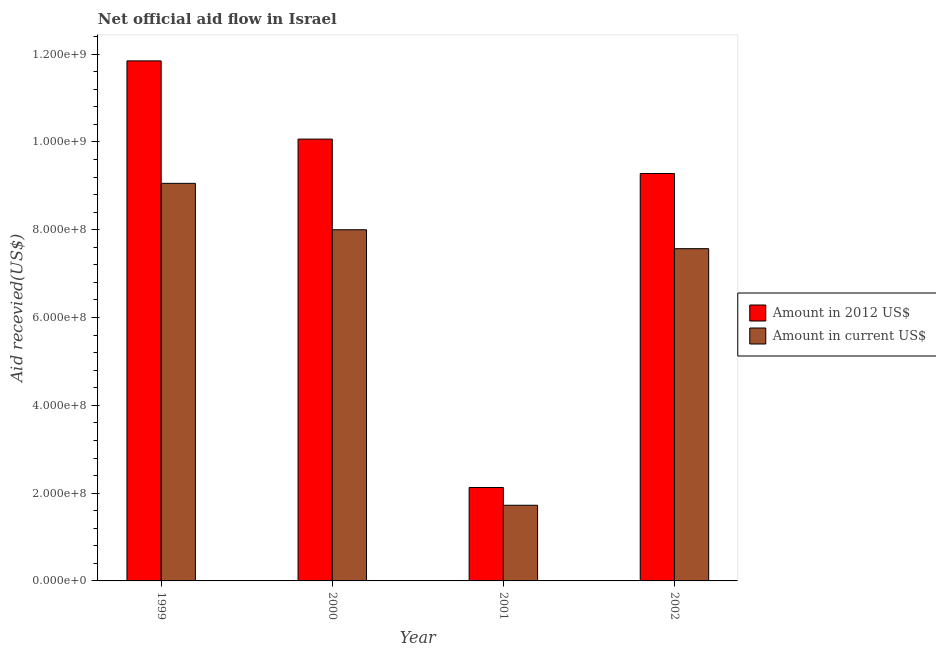How many different coloured bars are there?
Your answer should be compact. 2. How many bars are there on the 1st tick from the left?
Offer a very short reply. 2. How many bars are there on the 3rd tick from the right?
Your answer should be very brief. 2. In how many cases, is the number of bars for a given year not equal to the number of legend labels?
Offer a terse response. 0. What is the amount of aid received(expressed in us$) in 2001?
Offer a very short reply. 1.72e+08. Across all years, what is the maximum amount of aid received(expressed in 2012 us$)?
Your answer should be compact. 1.18e+09. Across all years, what is the minimum amount of aid received(expressed in 2012 us$)?
Give a very brief answer. 2.13e+08. In which year was the amount of aid received(expressed in us$) maximum?
Make the answer very short. 1999. In which year was the amount of aid received(expressed in us$) minimum?
Your answer should be very brief. 2001. What is the total amount of aid received(expressed in us$) in the graph?
Offer a very short reply. 2.63e+09. What is the difference between the amount of aid received(expressed in 2012 us$) in 2001 and that in 2002?
Your answer should be compact. -7.15e+08. What is the difference between the amount of aid received(expressed in us$) in 2001 and the amount of aid received(expressed in 2012 us$) in 1999?
Keep it short and to the point. -7.33e+08. What is the average amount of aid received(expressed in 2012 us$) per year?
Ensure brevity in your answer.  8.33e+08. In the year 2001, what is the difference between the amount of aid received(expressed in 2012 us$) and amount of aid received(expressed in us$)?
Give a very brief answer. 0. In how many years, is the amount of aid received(expressed in 2012 us$) greater than 800000000 US$?
Offer a terse response. 3. What is the ratio of the amount of aid received(expressed in 2012 us$) in 2000 to that in 2002?
Provide a succinct answer. 1.08. Is the amount of aid received(expressed in us$) in 2000 less than that in 2001?
Offer a terse response. No. Is the difference between the amount of aid received(expressed in 2012 us$) in 1999 and 2002 greater than the difference between the amount of aid received(expressed in us$) in 1999 and 2002?
Ensure brevity in your answer.  No. What is the difference between the highest and the second highest amount of aid received(expressed in 2012 us$)?
Provide a short and direct response. 1.78e+08. What is the difference between the highest and the lowest amount of aid received(expressed in 2012 us$)?
Ensure brevity in your answer.  9.72e+08. Is the sum of the amount of aid received(expressed in us$) in 2001 and 2002 greater than the maximum amount of aid received(expressed in 2012 us$) across all years?
Your answer should be compact. Yes. What does the 2nd bar from the left in 1999 represents?
Make the answer very short. Amount in current US$. What does the 1st bar from the right in 2000 represents?
Your response must be concise. Amount in current US$. How many years are there in the graph?
Your response must be concise. 4. What is the difference between two consecutive major ticks on the Y-axis?
Ensure brevity in your answer.  2.00e+08. Are the values on the major ticks of Y-axis written in scientific E-notation?
Provide a succinct answer. Yes. How are the legend labels stacked?
Offer a very short reply. Vertical. What is the title of the graph?
Make the answer very short. Net official aid flow in Israel. Does "Exports of goods" appear as one of the legend labels in the graph?
Your response must be concise. No. What is the label or title of the Y-axis?
Ensure brevity in your answer.  Aid recevied(US$). What is the Aid recevied(US$) in Amount in 2012 US$ in 1999?
Your response must be concise. 1.18e+09. What is the Aid recevied(US$) in Amount in current US$ in 1999?
Keep it short and to the point. 9.06e+08. What is the Aid recevied(US$) of Amount in 2012 US$ in 2000?
Make the answer very short. 1.01e+09. What is the Aid recevied(US$) of Amount in current US$ in 2000?
Provide a short and direct response. 8.00e+08. What is the Aid recevied(US$) in Amount in 2012 US$ in 2001?
Offer a terse response. 2.13e+08. What is the Aid recevied(US$) in Amount in current US$ in 2001?
Your response must be concise. 1.72e+08. What is the Aid recevied(US$) of Amount in 2012 US$ in 2002?
Provide a short and direct response. 9.28e+08. What is the Aid recevied(US$) in Amount in current US$ in 2002?
Your answer should be very brief. 7.57e+08. Across all years, what is the maximum Aid recevied(US$) in Amount in 2012 US$?
Provide a short and direct response. 1.18e+09. Across all years, what is the maximum Aid recevied(US$) in Amount in current US$?
Provide a succinct answer. 9.06e+08. Across all years, what is the minimum Aid recevied(US$) of Amount in 2012 US$?
Your response must be concise. 2.13e+08. Across all years, what is the minimum Aid recevied(US$) in Amount in current US$?
Keep it short and to the point. 1.72e+08. What is the total Aid recevied(US$) of Amount in 2012 US$ in the graph?
Offer a terse response. 3.33e+09. What is the total Aid recevied(US$) in Amount in current US$ in the graph?
Provide a succinct answer. 2.63e+09. What is the difference between the Aid recevied(US$) in Amount in 2012 US$ in 1999 and that in 2000?
Provide a short and direct response. 1.78e+08. What is the difference between the Aid recevied(US$) in Amount in current US$ in 1999 and that in 2000?
Provide a short and direct response. 1.06e+08. What is the difference between the Aid recevied(US$) in Amount in 2012 US$ in 1999 and that in 2001?
Keep it short and to the point. 9.72e+08. What is the difference between the Aid recevied(US$) in Amount in current US$ in 1999 and that in 2001?
Your answer should be compact. 7.33e+08. What is the difference between the Aid recevied(US$) in Amount in 2012 US$ in 1999 and that in 2002?
Keep it short and to the point. 2.57e+08. What is the difference between the Aid recevied(US$) of Amount in current US$ in 1999 and that in 2002?
Make the answer very short. 1.49e+08. What is the difference between the Aid recevied(US$) of Amount in 2012 US$ in 2000 and that in 2001?
Offer a terse response. 7.94e+08. What is the difference between the Aid recevied(US$) in Amount in current US$ in 2000 and that in 2001?
Offer a terse response. 6.28e+08. What is the difference between the Aid recevied(US$) of Amount in 2012 US$ in 2000 and that in 2002?
Your answer should be compact. 7.83e+07. What is the difference between the Aid recevied(US$) of Amount in current US$ in 2000 and that in 2002?
Offer a very short reply. 4.31e+07. What is the difference between the Aid recevied(US$) of Amount in 2012 US$ in 2001 and that in 2002?
Your answer should be very brief. -7.15e+08. What is the difference between the Aid recevied(US$) in Amount in current US$ in 2001 and that in 2002?
Provide a succinct answer. -5.85e+08. What is the difference between the Aid recevied(US$) of Amount in 2012 US$ in 1999 and the Aid recevied(US$) of Amount in current US$ in 2000?
Ensure brevity in your answer.  3.85e+08. What is the difference between the Aid recevied(US$) of Amount in 2012 US$ in 1999 and the Aid recevied(US$) of Amount in current US$ in 2001?
Your response must be concise. 1.01e+09. What is the difference between the Aid recevied(US$) in Amount in 2012 US$ in 1999 and the Aid recevied(US$) in Amount in current US$ in 2002?
Provide a succinct answer. 4.28e+08. What is the difference between the Aid recevied(US$) in Amount in 2012 US$ in 2000 and the Aid recevied(US$) in Amount in current US$ in 2001?
Make the answer very short. 8.34e+08. What is the difference between the Aid recevied(US$) of Amount in 2012 US$ in 2000 and the Aid recevied(US$) of Amount in current US$ in 2002?
Your answer should be compact. 2.50e+08. What is the difference between the Aid recevied(US$) of Amount in 2012 US$ in 2001 and the Aid recevied(US$) of Amount in current US$ in 2002?
Your answer should be compact. -5.44e+08. What is the average Aid recevied(US$) in Amount in 2012 US$ per year?
Your answer should be very brief. 8.33e+08. What is the average Aid recevied(US$) of Amount in current US$ per year?
Give a very brief answer. 6.59e+08. In the year 1999, what is the difference between the Aid recevied(US$) in Amount in 2012 US$ and Aid recevied(US$) in Amount in current US$?
Provide a short and direct response. 2.79e+08. In the year 2000, what is the difference between the Aid recevied(US$) in Amount in 2012 US$ and Aid recevied(US$) in Amount in current US$?
Keep it short and to the point. 2.06e+08. In the year 2001, what is the difference between the Aid recevied(US$) in Amount in 2012 US$ and Aid recevied(US$) in Amount in current US$?
Provide a succinct answer. 4.05e+07. In the year 2002, what is the difference between the Aid recevied(US$) in Amount in 2012 US$ and Aid recevied(US$) in Amount in current US$?
Offer a terse response. 1.71e+08. What is the ratio of the Aid recevied(US$) in Amount in 2012 US$ in 1999 to that in 2000?
Ensure brevity in your answer.  1.18. What is the ratio of the Aid recevied(US$) of Amount in current US$ in 1999 to that in 2000?
Your response must be concise. 1.13. What is the ratio of the Aid recevied(US$) of Amount in 2012 US$ in 1999 to that in 2001?
Your answer should be compact. 5.57. What is the ratio of the Aid recevied(US$) of Amount in current US$ in 1999 to that in 2001?
Your response must be concise. 5.26. What is the ratio of the Aid recevied(US$) in Amount in 2012 US$ in 1999 to that in 2002?
Offer a terse response. 1.28. What is the ratio of the Aid recevied(US$) of Amount in current US$ in 1999 to that in 2002?
Your response must be concise. 1.2. What is the ratio of the Aid recevied(US$) of Amount in 2012 US$ in 2000 to that in 2001?
Offer a very short reply. 4.73. What is the ratio of the Aid recevied(US$) of Amount in current US$ in 2000 to that in 2001?
Make the answer very short. 4.64. What is the ratio of the Aid recevied(US$) of Amount in 2012 US$ in 2000 to that in 2002?
Your answer should be compact. 1.08. What is the ratio of the Aid recevied(US$) of Amount in current US$ in 2000 to that in 2002?
Offer a very short reply. 1.06. What is the ratio of the Aid recevied(US$) in Amount in 2012 US$ in 2001 to that in 2002?
Make the answer very short. 0.23. What is the ratio of the Aid recevied(US$) of Amount in current US$ in 2001 to that in 2002?
Give a very brief answer. 0.23. What is the difference between the highest and the second highest Aid recevied(US$) of Amount in 2012 US$?
Make the answer very short. 1.78e+08. What is the difference between the highest and the second highest Aid recevied(US$) of Amount in current US$?
Your answer should be compact. 1.06e+08. What is the difference between the highest and the lowest Aid recevied(US$) in Amount in 2012 US$?
Provide a short and direct response. 9.72e+08. What is the difference between the highest and the lowest Aid recevied(US$) of Amount in current US$?
Provide a short and direct response. 7.33e+08. 